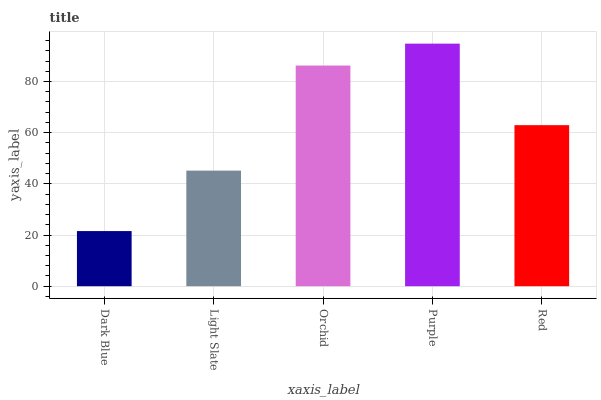Is Dark Blue the minimum?
Answer yes or no. Yes. Is Purple the maximum?
Answer yes or no. Yes. Is Light Slate the minimum?
Answer yes or no. No. Is Light Slate the maximum?
Answer yes or no. No. Is Light Slate greater than Dark Blue?
Answer yes or no. Yes. Is Dark Blue less than Light Slate?
Answer yes or no. Yes. Is Dark Blue greater than Light Slate?
Answer yes or no. No. Is Light Slate less than Dark Blue?
Answer yes or no. No. Is Red the high median?
Answer yes or no. Yes. Is Red the low median?
Answer yes or no. Yes. Is Dark Blue the high median?
Answer yes or no. No. Is Purple the low median?
Answer yes or no. No. 